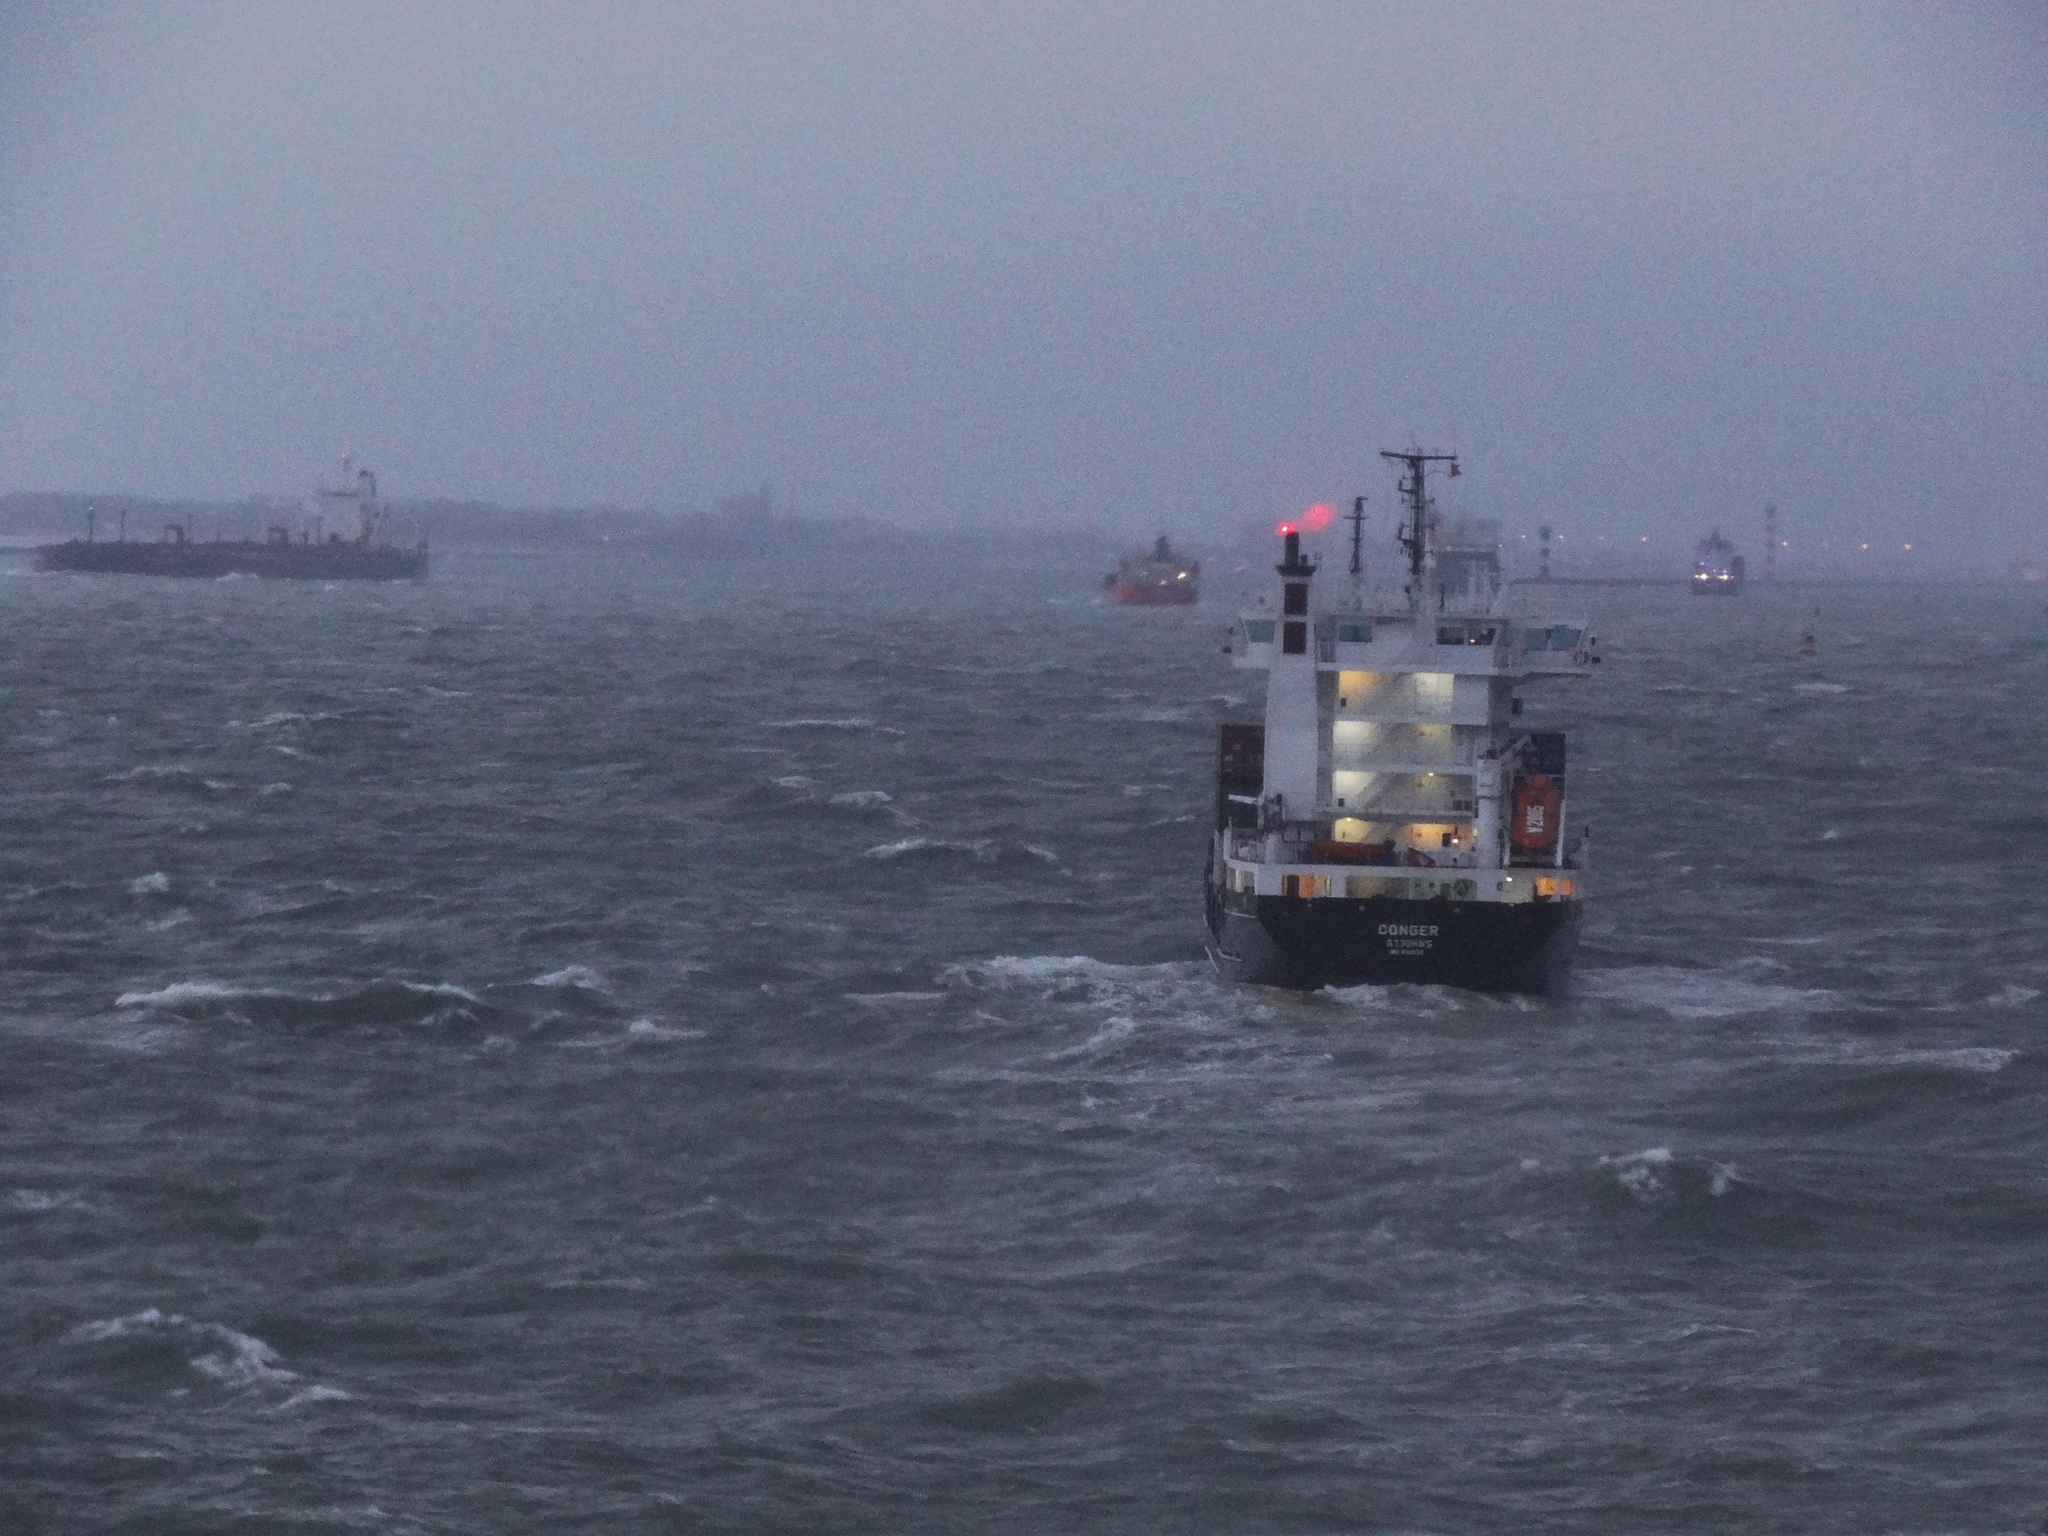What is the main subject of the image? The main subject of the image is ships. Where are the ships located in relation to the water? The ships are above the water in the image. What else can be seen in the image besides the ships? There are lights and poles visible in the image. What is visible in the background of the image? The sky is visible in the background of the image. What type of cakes are being served for lunch in the image? There is no mention of lunch or cakes in the image; it features ships above the water with lights and poles visible. 